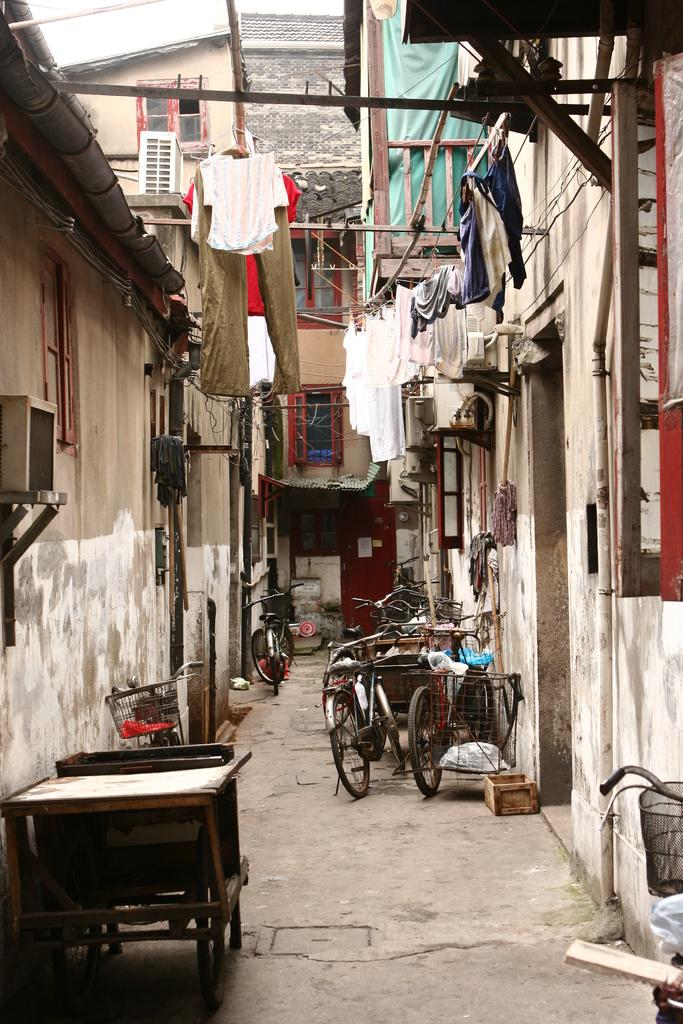Where was the image taken? The image was taken in a street. What can be seen in the middle of the image? There are many cycles in the middle of the image. What is on the left side of the image? There is a wall, a cycle, and a window on the left side of the image. What is on the right side of the image? There is a building on the right side of the image. How many spiders are crawling on the quilt in the image? There is no quilt or spiders present in the image. What type of worm can be seen on the building in the image? There are no worms present in the image; the building is the only structure visible on the right side. 